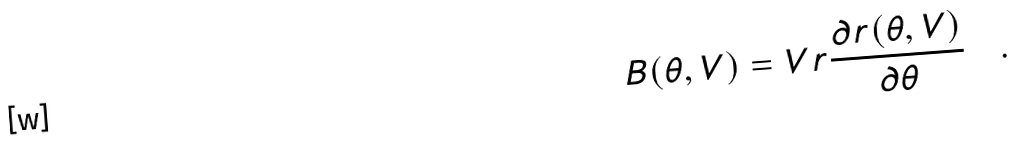<formula> <loc_0><loc_0><loc_500><loc_500>B ( \theta , V ) = V r \frac { \partial r ( \theta , V ) } { \partial \theta } \quad .</formula> 